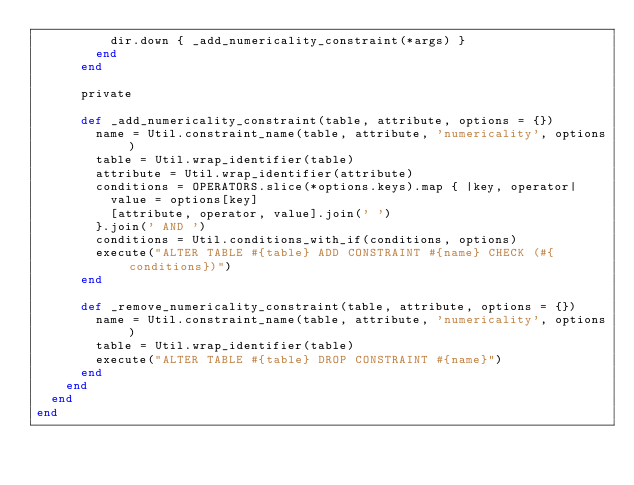<code> <loc_0><loc_0><loc_500><loc_500><_Ruby_>          dir.down { _add_numericality_constraint(*args) }
        end
      end

      private

      def _add_numericality_constraint(table, attribute, options = {})
        name = Util.constraint_name(table, attribute, 'numericality', options)
        table = Util.wrap_identifier(table)
        attribute = Util.wrap_identifier(attribute)
        conditions = OPERATORS.slice(*options.keys).map { |key, operator|
          value = options[key]
          [attribute, operator, value].join(' ')
        }.join(' AND ')
        conditions = Util.conditions_with_if(conditions, options)
        execute("ALTER TABLE #{table} ADD CONSTRAINT #{name} CHECK (#{conditions})")
      end

      def _remove_numericality_constraint(table, attribute, options = {})
        name = Util.constraint_name(table, attribute, 'numericality', options)
        table = Util.wrap_identifier(table)
        execute("ALTER TABLE #{table} DROP CONSTRAINT #{name}")
      end
    end
  end
end
</code> 